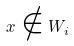Convert formula to latex. <formula><loc_0><loc_0><loc_500><loc_500>x \notin W _ { i }</formula> 